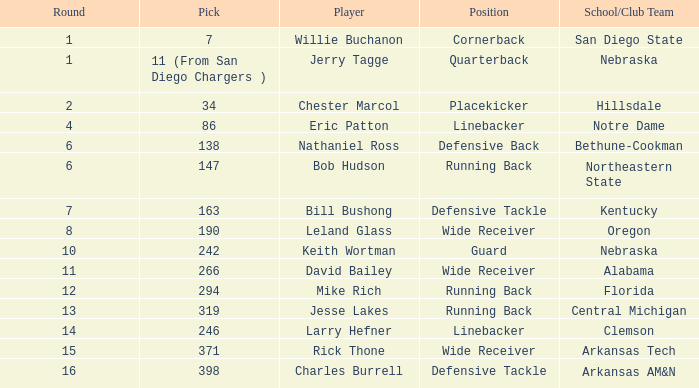Which player is it that has a pick of 147? Bob Hudson. Write the full table. {'header': ['Round', 'Pick', 'Player', 'Position', 'School/Club Team'], 'rows': [['1', '7', 'Willie Buchanon', 'Cornerback', 'San Diego State'], ['1', '11 (From San Diego Chargers )', 'Jerry Tagge', 'Quarterback', 'Nebraska'], ['2', '34', 'Chester Marcol', 'Placekicker', 'Hillsdale'], ['4', '86', 'Eric Patton', 'Linebacker', 'Notre Dame'], ['6', '138', 'Nathaniel Ross', 'Defensive Back', 'Bethune-Cookman'], ['6', '147', 'Bob Hudson', 'Running Back', 'Northeastern State'], ['7', '163', 'Bill Bushong', 'Defensive Tackle', 'Kentucky'], ['8', '190', 'Leland Glass', 'Wide Receiver', 'Oregon'], ['10', '242', 'Keith Wortman', 'Guard', 'Nebraska'], ['11', '266', 'David Bailey', 'Wide Receiver', 'Alabama'], ['12', '294', 'Mike Rich', 'Running Back', 'Florida'], ['13', '319', 'Jesse Lakes', 'Running Back', 'Central Michigan'], ['14', '246', 'Larry Hefner', 'Linebacker', 'Clemson'], ['15', '371', 'Rick Thone', 'Wide Receiver', 'Arkansas Tech'], ['16', '398', 'Charles Burrell', 'Defensive Tackle', 'Arkansas AM&N']]} 